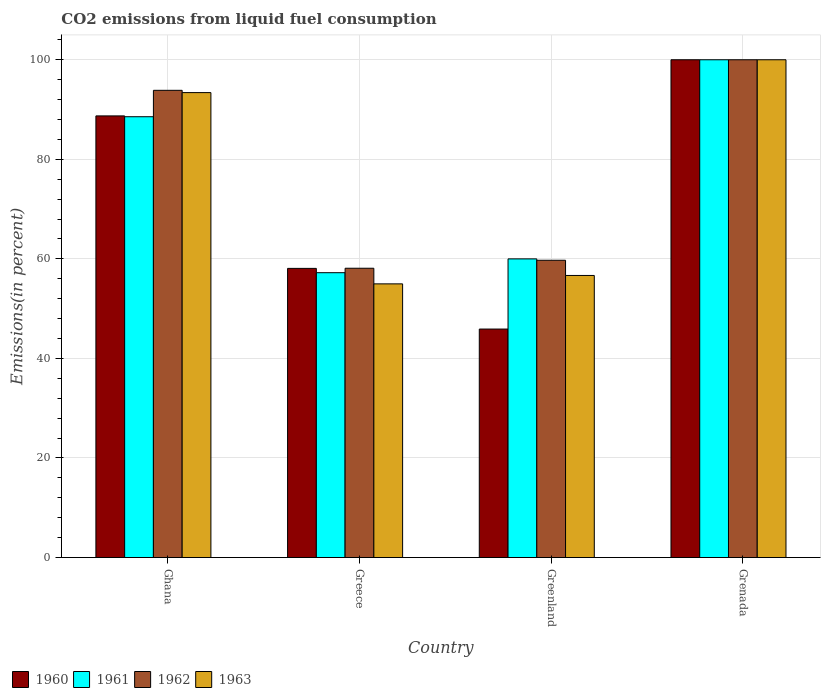How many different coloured bars are there?
Your response must be concise. 4. How many groups of bars are there?
Your answer should be compact. 4. Are the number of bars per tick equal to the number of legend labels?
Provide a succinct answer. Yes. What is the label of the 2nd group of bars from the left?
Offer a very short reply. Greece. Across all countries, what is the minimum total CO2 emitted in 1961?
Make the answer very short. 57.22. In which country was the total CO2 emitted in 1963 maximum?
Your answer should be very brief. Grenada. What is the total total CO2 emitted in 1961 in the graph?
Offer a very short reply. 305.78. What is the difference between the total CO2 emitted in 1963 in Ghana and that in Greenland?
Offer a very short reply. 36.74. What is the difference between the total CO2 emitted in 1962 in Ghana and the total CO2 emitted in 1961 in Grenada?
Your answer should be very brief. -6.14. What is the average total CO2 emitted in 1961 per country?
Your answer should be compact. 76.44. What is the difference between the total CO2 emitted of/in 1960 and total CO2 emitted of/in 1961 in Greenland?
Make the answer very short. -14.1. What is the ratio of the total CO2 emitted in 1960 in Ghana to that in Greenland?
Provide a succinct answer. 1.93. Is the difference between the total CO2 emitted in 1960 in Ghana and Grenada greater than the difference between the total CO2 emitted in 1961 in Ghana and Grenada?
Offer a terse response. Yes. What is the difference between the highest and the second highest total CO2 emitted in 1963?
Give a very brief answer. -43.33. What is the difference between the highest and the lowest total CO2 emitted in 1963?
Your answer should be very brief. 45.02. Is it the case that in every country, the sum of the total CO2 emitted in 1961 and total CO2 emitted in 1963 is greater than the sum of total CO2 emitted in 1962 and total CO2 emitted in 1960?
Provide a succinct answer. No. What does the 3rd bar from the left in Greece represents?
Make the answer very short. 1962. How many countries are there in the graph?
Ensure brevity in your answer.  4. What is the difference between two consecutive major ticks on the Y-axis?
Give a very brief answer. 20. How many legend labels are there?
Provide a short and direct response. 4. What is the title of the graph?
Offer a terse response. CO2 emissions from liquid fuel consumption. Does "1968" appear as one of the legend labels in the graph?
Ensure brevity in your answer.  No. What is the label or title of the Y-axis?
Provide a succinct answer. Emissions(in percent). What is the Emissions(in percent) in 1960 in Ghana?
Provide a succinct answer. 88.72. What is the Emissions(in percent) of 1961 in Ghana?
Make the answer very short. 88.56. What is the Emissions(in percent) of 1962 in Ghana?
Your answer should be very brief. 93.86. What is the Emissions(in percent) in 1963 in Ghana?
Offer a terse response. 93.4. What is the Emissions(in percent) in 1960 in Greece?
Your answer should be very brief. 58.09. What is the Emissions(in percent) in 1961 in Greece?
Provide a succinct answer. 57.22. What is the Emissions(in percent) in 1962 in Greece?
Ensure brevity in your answer.  58.12. What is the Emissions(in percent) in 1963 in Greece?
Offer a terse response. 54.98. What is the Emissions(in percent) in 1960 in Greenland?
Your answer should be very brief. 45.9. What is the Emissions(in percent) of 1962 in Greenland?
Your answer should be very brief. 59.72. What is the Emissions(in percent) in 1963 in Greenland?
Your response must be concise. 56.67. Across all countries, what is the minimum Emissions(in percent) of 1960?
Your response must be concise. 45.9. Across all countries, what is the minimum Emissions(in percent) of 1961?
Give a very brief answer. 57.22. Across all countries, what is the minimum Emissions(in percent) in 1962?
Your response must be concise. 58.12. Across all countries, what is the minimum Emissions(in percent) in 1963?
Your answer should be very brief. 54.98. What is the total Emissions(in percent) in 1960 in the graph?
Keep it short and to the point. 292.71. What is the total Emissions(in percent) in 1961 in the graph?
Ensure brevity in your answer.  305.78. What is the total Emissions(in percent) in 1962 in the graph?
Keep it short and to the point. 311.7. What is the total Emissions(in percent) in 1963 in the graph?
Your answer should be compact. 305.05. What is the difference between the Emissions(in percent) in 1960 in Ghana and that in Greece?
Give a very brief answer. 30.63. What is the difference between the Emissions(in percent) of 1961 in Ghana and that in Greece?
Your response must be concise. 31.33. What is the difference between the Emissions(in percent) of 1962 in Ghana and that in Greece?
Your answer should be compact. 35.74. What is the difference between the Emissions(in percent) of 1963 in Ghana and that in Greece?
Offer a terse response. 38.42. What is the difference between the Emissions(in percent) in 1960 in Ghana and that in Greenland?
Provide a succinct answer. 42.82. What is the difference between the Emissions(in percent) of 1961 in Ghana and that in Greenland?
Keep it short and to the point. 28.56. What is the difference between the Emissions(in percent) in 1962 in Ghana and that in Greenland?
Make the answer very short. 34.14. What is the difference between the Emissions(in percent) of 1963 in Ghana and that in Greenland?
Your answer should be very brief. 36.74. What is the difference between the Emissions(in percent) of 1960 in Ghana and that in Grenada?
Your response must be concise. -11.28. What is the difference between the Emissions(in percent) of 1961 in Ghana and that in Grenada?
Ensure brevity in your answer.  -11.44. What is the difference between the Emissions(in percent) in 1962 in Ghana and that in Grenada?
Make the answer very short. -6.14. What is the difference between the Emissions(in percent) of 1963 in Ghana and that in Grenada?
Offer a terse response. -6.6. What is the difference between the Emissions(in percent) in 1960 in Greece and that in Greenland?
Your answer should be very brief. 12.19. What is the difference between the Emissions(in percent) in 1961 in Greece and that in Greenland?
Offer a terse response. -2.78. What is the difference between the Emissions(in percent) in 1962 in Greece and that in Greenland?
Provide a succinct answer. -1.61. What is the difference between the Emissions(in percent) in 1963 in Greece and that in Greenland?
Provide a succinct answer. -1.69. What is the difference between the Emissions(in percent) of 1960 in Greece and that in Grenada?
Your answer should be very brief. -41.91. What is the difference between the Emissions(in percent) in 1961 in Greece and that in Grenada?
Provide a succinct answer. -42.78. What is the difference between the Emissions(in percent) of 1962 in Greece and that in Grenada?
Your response must be concise. -41.88. What is the difference between the Emissions(in percent) in 1963 in Greece and that in Grenada?
Your response must be concise. -45.02. What is the difference between the Emissions(in percent) in 1960 in Greenland and that in Grenada?
Provide a succinct answer. -54.1. What is the difference between the Emissions(in percent) of 1962 in Greenland and that in Grenada?
Keep it short and to the point. -40.28. What is the difference between the Emissions(in percent) in 1963 in Greenland and that in Grenada?
Provide a short and direct response. -43.33. What is the difference between the Emissions(in percent) of 1960 in Ghana and the Emissions(in percent) of 1961 in Greece?
Ensure brevity in your answer.  31.5. What is the difference between the Emissions(in percent) of 1960 in Ghana and the Emissions(in percent) of 1962 in Greece?
Make the answer very short. 30.6. What is the difference between the Emissions(in percent) in 1960 in Ghana and the Emissions(in percent) in 1963 in Greece?
Offer a terse response. 33.74. What is the difference between the Emissions(in percent) in 1961 in Ghana and the Emissions(in percent) in 1962 in Greece?
Offer a very short reply. 30.44. What is the difference between the Emissions(in percent) in 1961 in Ghana and the Emissions(in percent) in 1963 in Greece?
Your answer should be compact. 33.58. What is the difference between the Emissions(in percent) of 1962 in Ghana and the Emissions(in percent) of 1963 in Greece?
Ensure brevity in your answer.  38.88. What is the difference between the Emissions(in percent) of 1960 in Ghana and the Emissions(in percent) of 1961 in Greenland?
Keep it short and to the point. 28.72. What is the difference between the Emissions(in percent) of 1960 in Ghana and the Emissions(in percent) of 1962 in Greenland?
Provide a succinct answer. 29. What is the difference between the Emissions(in percent) of 1960 in Ghana and the Emissions(in percent) of 1963 in Greenland?
Provide a succinct answer. 32.06. What is the difference between the Emissions(in percent) of 1961 in Ghana and the Emissions(in percent) of 1962 in Greenland?
Your answer should be very brief. 28.83. What is the difference between the Emissions(in percent) in 1961 in Ghana and the Emissions(in percent) in 1963 in Greenland?
Offer a terse response. 31.89. What is the difference between the Emissions(in percent) in 1962 in Ghana and the Emissions(in percent) in 1963 in Greenland?
Keep it short and to the point. 37.2. What is the difference between the Emissions(in percent) of 1960 in Ghana and the Emissions(in percent) of 1961 in Grenada?
Give a very brief answer. -11.28. What is the difference between the Emissions(in percent) of 1960 in Ghana and the Emissions(in percent) of 1962 in Grenada?
Your response must be concise. -11.28. What is the difference between the Emissions(in percent) of 1960 in Ghana and the Emissions(in percent) of 1963 in Grenada?
Your answer should be very brief. -11.28. What is the difference between the Emissions(in percent) in 1961 in Ghana and the Emissions(in percent) in 1962 in Grenada?
Make the answer very short. -11.44. What is the difference between the Emissions(in percent) of 1961 in Ghana and the Emissions(in percent) of 1963 in Grenada?
Keep it short and to the point. -11.44. What is the difference between the Emissions(in percent) of 1962 in Ghana and the Emissions(in percent) of 1963 in Grenada?
Your response must be concise. -6.14. What is the difference between the Emissions(in percent) of 1960 in Greece and the Emissions(in percent) of 1961 in Greenland?
Your response must be concise. -1.91. What is the difference between the Emissions(in percent) in 1960 in Greece and the Emissions(in percent) in 1962 in Greenland?
Provide a succinct answer. -1.63. What is the difference between the Emissions(in percent) of 1960 in Greece and the Emissions(in percent) of 1963 in Greenland?
Provide a short and direct response. 1.42. What is the difference between the Emissions(in percent) of 1961 in Greece and the Emissions(in percent) of 1962 in Greenland?
Your answer should be very brief. -2.5. What is the difference between the Emissions(in percent) of 1961 in Greece and the Emissions(in percent) of 1963 in Greenland?
Your response must be concise. 0.56. What is the difference between the Emissions(in percent) in 1962 in Greece and the Emissions(in percent) in 1963 in Greenland?
Keep it short and to the point. 1.45. What is the difference between the Emissions(in percent) of 1960 in Greece and the Emissions(in percent) of 1961 in Grenada?
Your answer should be compact. -41.91. What is the difference between the Emissions(in percent) in 1960 in Greece and the Emissions(in percent) in 1962 in Grenada?
Give a very brief answer. -41.91. What is the difference between the Emissions(in percent) in 1960 in Greece and the Emissions(in percent) in 1963 in Grenada?
Your response must be concise. -41.91. What is the difference between the Emissions(in percent) of 1961 in Greece and the Emissions(in percent) of 1962 in Grenada?
Give a very brief answer. -42.78. What is the difference between the Emissions(in percent) of 1961 in Greece and the Emissions(in percent) of 1963 in Grenada?
Keep it short and to the point. -42.78. What is the difference between the Emissions(in percent) in 1962 in Greece and the Emissions(in percent) in 1963 in Grenada?
Make the answer very short. -41.88. What is the difference between the Emissions(in percent) of 1960 in Greenland and the Emissions(in percent) of 1961 in Grenada?
Offer a very short reply. -54.1. What is the difference between the Emissions(in percent) in 1960 in Greenland and the Emissions(in percent) in 1962 in Grenada?
Provide a short and direct response. -54.1. What is the difference between the Emissions(in percent) of 1960 in Greenland and the Emissions(in percent) of 1963 in Grenada?
Offer a very short reply. -54.1. What is the difference between the Emissions(in percent) of 1961 in Greenland and the Emissions(in percent) of 1962 in Grenada?
Your answer should be compact. -40. What is the difference between the Emissions(in percent) in 1962 in Greenland and the Emissions(in percent) in 1963 in Grenada?
Ensure brevity in your answer.  -40.28. What is the average Emissions(in percent) in 1960 per country?
Your answer should be compact. 73.18. What is the average Emissions(in percent) of 1961 per country?
Your answer should be compact. 76.44. What is the average Emissions(in percent) in 1962 per country?
Your answer should be very brief. 77.93. What is the average Emissions(in percent) of 1963 per country?
Your response must be concise. 76.26. What is the difference between the Emissions(in percent) in 1960 and Emissions(in percent) in 1961 in Ghana?
Make the answer very short. 0.17. What is the difference between the Emissions(in percent) in 1960 and Emissions(in percent) in 1962 in Ghana?
Give a very brief answer. -5.14. What is the difference between the Emissions(in percent) of 1960 and Emissions(in percent) of 1963 in Ghana?
Ensure brevity in your answer.  -4.68. What is the difference between the Emissions(in percent) in 1961 and Emissions(in percent) in 1962 in Ghana?
Offer a terse response. -5.31. What is the difference between the Emissions(in percent) of 1961 and Emissions(in percent) of 1963 in Ghana?
Give a very brief answer. -4.85. What is the difference between the Emissions(in percent) in 1962 and Emissions(in percent) in 1963 in Ghana?
Your response must be concise. 0.46. What is the difference between the Emissions(in percent) of 1960 and Emissions(in percent) of 1961 in Greece?
Keep it short and to the point. 0.87. What is the difference between the Emissions(in percent) in 1960 and Emissions(in percent) in 1962 in Greece?
Ensure brevity in your answer.  -0.03. What is the difference between the Emissions(in percent) in 1960 and Emissions(in percent) in 1963 in Greece?
Ensure brevity in your answer.  3.11. What is the difference between the Emissions(in percent) in 1961 and Emissions(in percent) in 1962 in Greece?
Provide a short and direct response. -0.89. What is the difference between the Emissions(in percent) of 1961 and Emissions(in percent) of 1963 in Greece?
Offer a terse response. 2.24. What is the difference between the Emissions(in percent) of 1962 and Emissions(in percent) of 1963 in Greece?
Provide a short and direct response. 3.14. What is the difference between the Emissions(in percent) in 1960 and Emissions(in percent) in 1961 in Greenland?
Give a very brief answer. -14.1. What is the difference between the Emissions(in percent) of 1960 and Emissions(in percent) of 1962 in Greenland?
Offer a very short reply. -13.82. What is the difference between the Emissions(in percent) of 1960 and Emissions(in percent) of 1963 in Greenland?
Provide a short and direct response. -10.77. What is the difference between the Emissions(in percent) in 1961 and Emissions(in percent) in 1962 in Greenland?
Your answer should be compact. 0.28. What is the difference between the Emissions(in percent) of 1962 and Emissions(in percent) of 1963 in Greenland?
Your answer should be compact. 3.06. What is the difference between the Emissions(in percent) in 1960 and Emissions(in percent) in 1962 in Grenada?
Give a very brief answer. 0. What is the difference between the Emissions(in percent) of 1961 and Emissions(in percent) of 1963 in Grenada?
Your answer should be very brief. 0. What is the difference between the Emissions(in percent) of 1962 and Emissions(in percent) of 1963 in Grenada?
Give a very brief answer. 0. What is the ratio of the Emissions(in percent) in 1960 in Ghana to that in Greece?
Your response must be concise. 1.53. What is the ratio of the Emissions(in percent) in 1961 in Ghana to that in Greece?
Ensure brevity in your answer.  1.55. What is the ratio of the Emissions(in percent) in 1962 in Ghana to that in Greece?
Give a very brief answer. 1.62. What is the ratio of the Emissions(in percent) of 1963 in Ghana to that in Greece?
Offer a very short reply. 1.7. What is the ratio of the Emissions(in percent) in 1960 in Ghana to that in Greenland?
Keep it short and to the point. 1.93. What is the ratio of the Emissions(in percent) of 1961 in Ghana to that in Greenland?
Your answer should be very brief. 1.48. What is the ratio of the Emissions(in percent) in 1962 in Ghana to that in Greenland?
Your answer should be very brief. 1.57. What is the ratio of the Emissions(in percent) in 1963 in Ghana to that in Greenland?
Give a very brief answer. 1.65. What is the ratio of the Emissions(in percent) in 1960 in Ghana to that in Grenada?
Offer a terse response. 0.89. What is the ratio of the Emissions(in percent) of 1961 in Ghana to that in Grenada?
Offer a terse response. 0.89. What is the ratio of the Emissions(in percent) of 1962 in Ghana to that in Grenada?
Offer a terse response. 0.94. What is the ratio of the Emissions(in percent) of 1963 in Ghana to that in Grenada?
Your answer should be very brief. 0.93. What is the ratio of the Emissions(in percent) of 1960 in Greece to that in Greenland?
Ensure brevity in your answer.  1.27. What is the ratio of the Emissions(in percent) of 1961 in Greece to that in Greenland?
Your answer should be compact. 0.95. What is the ratio of the Emissions(in percent) of 1962 in Greece to that in Greenland?
Provide a succinct answer. 0.97. What is the ratio of the Emissions(in percent) of 1963 in Greece to that in Greenland?
Your answer should be very brief. 0.97. What is the ratio of the Emissions(in percent) in 1960 in Greece to that in Grenada?
Keep it short and to the point. 0.58. What is the ratio of the Emissions(in percent) in 1961 in Greece to that in Grenada?
Keep it short and to the point. 0.57. What is the ratio of the Emissions(in percent) in 1962 in Greece to that in Grenada?
Provide a short and direct response. 0.58. What is the ratio of the Emissions(in percent) of 1963 in Greece to that in Grenada?
Offer a terse response. 0.55. What is the ratio of the Emissions(in percent) of 1960 in Greenland to that in Grenada?
Keep it short and to the point. 0.46. What is the ratio of the Emissions(in percent) of 1961 in Greenland to that in Grenada?
Give a very brief answer. 0.6. What is the ratio of the Emissions(in percent) of 1962 in Greenland to that in Grenada?
Offer a very short reply. 0.6. What is the ratio of the Emissions(in percent) in 1963 in Greenland to that in Grenada?
Make the answer very short. 0.57. What is the difference between the highest and the second highest Emissions(in percent) in 1960?
Your answer should be compact. 11.28. What is the difference between the highest and the second highest Emissions(in percent) of 1961?
Provide a short and direct response. 11.44. What is the difference between the highest and the second highest Emissions(in percent) of 1962?
Your response must be concise. 6.14. What is the difference between the highest and the second highest Emissions(in percent) of 1963?
Offer a terse response. 6.6. What is the difference between the highest and the lowest Emissions(in percent) of 1960?
Offer a very short reply. 54.1. What is the difference between the highest and the lowest Emissions(in percent) in 1961?
Offer a terse response. 42.78. What is the difference between the highest and the lowest Emissions(in percent) in 1962?
Give a very brief answer. 41.88. What is the difference between the highest and the lowest Emissions(in percent) of 1963?
Provide a short and direct response. 45.02. 